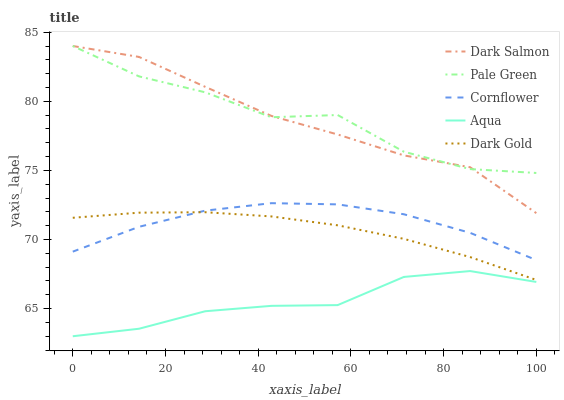Does Pale Green have the minimum area under the curve?
Answer yes or no. No. Does Aqua have the maximum area under the curve?
Answer yes or no. No. Is Aqua the smoothest?
Answer yes or no. No. Is Aqua the roughest?
Answer yes or no. No. Does Pale Green have the lowest value?
Answer yes or no. No. Does Aqua have the highest value?
Answer yes or no. No. Is Cornflower less than Pale Green?
Answer yes or no. Yes. Is Dark Gold greater than Aqua?
Answer yes or no. Yes. Does Cornflower intersect Pale Green?
Answer yes or no. No. 